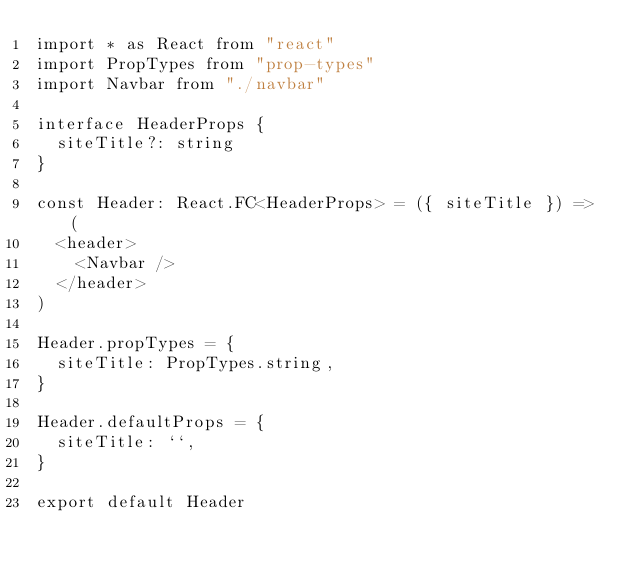Convert code to text. <code><loc_0><loc_0><loc_500><loc_500><_TypeScript_>import * as React from "react"
import PropTypes from "prop-types"
import Navbar from "./navbar"

interface HeaderProps {
  siteTitle?: string
}

const Header: React.FC<HeaderProps> = ({ siteTitle }) => (
  <header>
    <Navbar />
  </header>
)

Header.propTypes = {
  siteTitle: PropTypes.string,
}

Header.defaultProps = {
  siteTitle: ``,
}

export default Header
</code> 